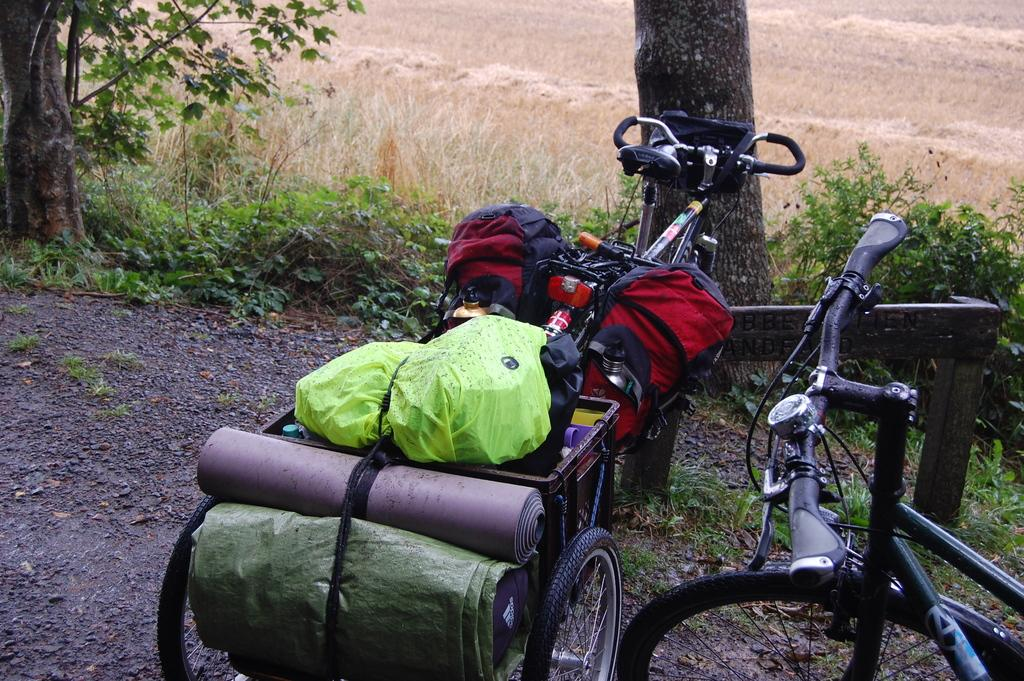What is the main object in the image? There is a bicycle in the image. Are there any distinguishing features on one of the bicycles? Yes, one of the bikes has bags and other objects attached to it. What can be seen in the background of the image? There is grass, plants, and trees in the background of the image. What type of addition problem can be solved using the numbers on the bicycle? There are no numbers or addition problems present on the bicycle in the image. 